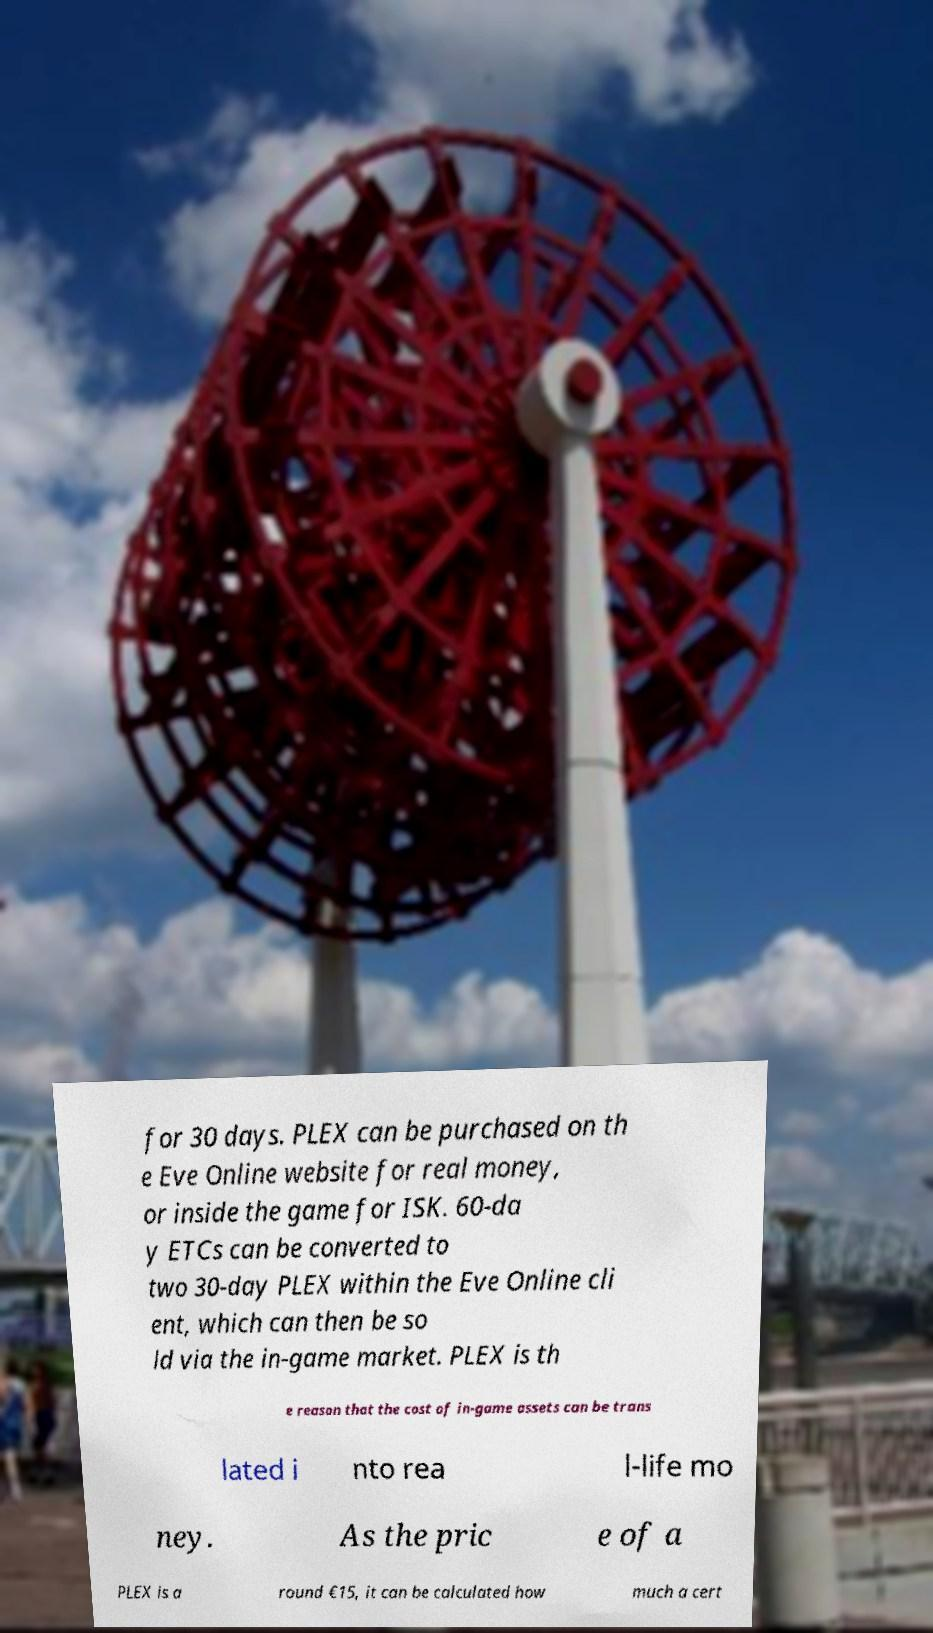Please read and relay the text visible in this image. What does it say? for 30 days. PLEX can be purchased on th e Eve Online website for real money, or inside the game for ISK. 60-da y ETCs can be converted to two 30-day PLEX within the Eve Online cli ent, which can then be so ld via the in-game market. PLEX is th e reason that the cost of in-game assets can be trans lated i nto rea l-life mo ney. As the pric e of a PLEX is a round €15, it can be calculated how much a cert 